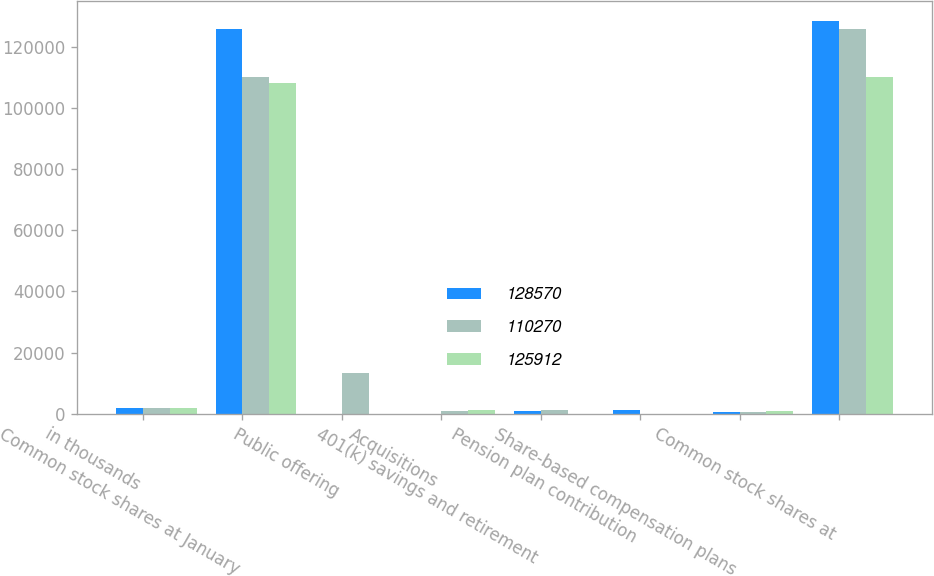<chart> <loc_0><loc_0><loc_500><loc_500><stacked_bar_chart><ecel><fcel>in thousands<fcel>Common stock shares at January<fcel>Public offering<fcel>Acquisitions<fcel>401(k) savings and retirement<fcel>Pension plan contribution<fcel>Share-based compensation plans<fcel>Common stock shares at<nl><fcel>128570<fcel>2010<fcel>125912<fcel>0<fcel>0<fcel>882<fcel>1190<fcel>586<fcel>128570<nl><fcel>110270<fcel>2009<fcel>110270<fcel>13225<fcel>789<fcel>1135<fcel>0<fcel>493<fcel>125912<nl><fcel>125912<fcel>2008<fcel>108234<fcel>0<fcel>1152<fcel>0<fcel>0<fcel>884<fcel>110270<nl></chart> 